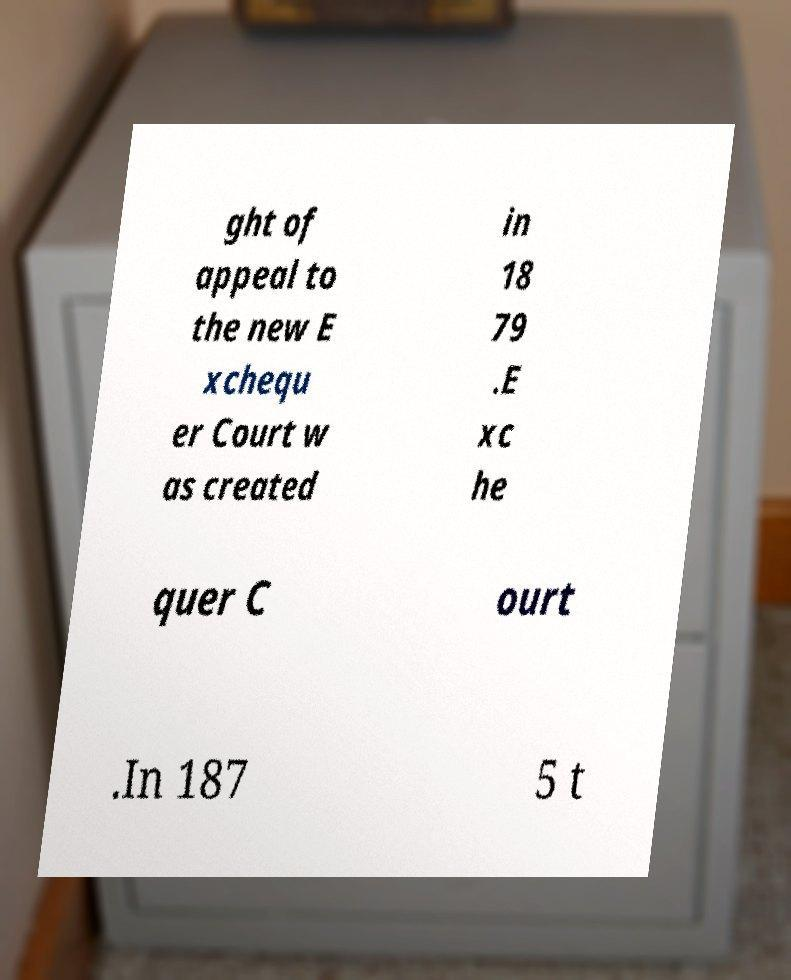I need the written content from this picture converted into text. Can you do that? ght of appeal to the new E xchequ er Court w as created in 18 79 .E xc he quer C ourt .In 187 5 t 